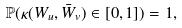<formula> <loc_0><loc_0><loc_500><loc_500>\mathbb { P } ( \kappa ( W _ { u } , \bar { W } _ { v } ) \in [ 0 , 1 ] ) = 1 ,</formula> 